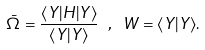<formula> <loc_0><loc_0><loc_500><loc_500>\bar { \Omega } = \frac { \langle Y | H | Y \rangle } { \langle Y | Y \rangle } \ , \ W = \langle Y | Y \rangle .</formula> 